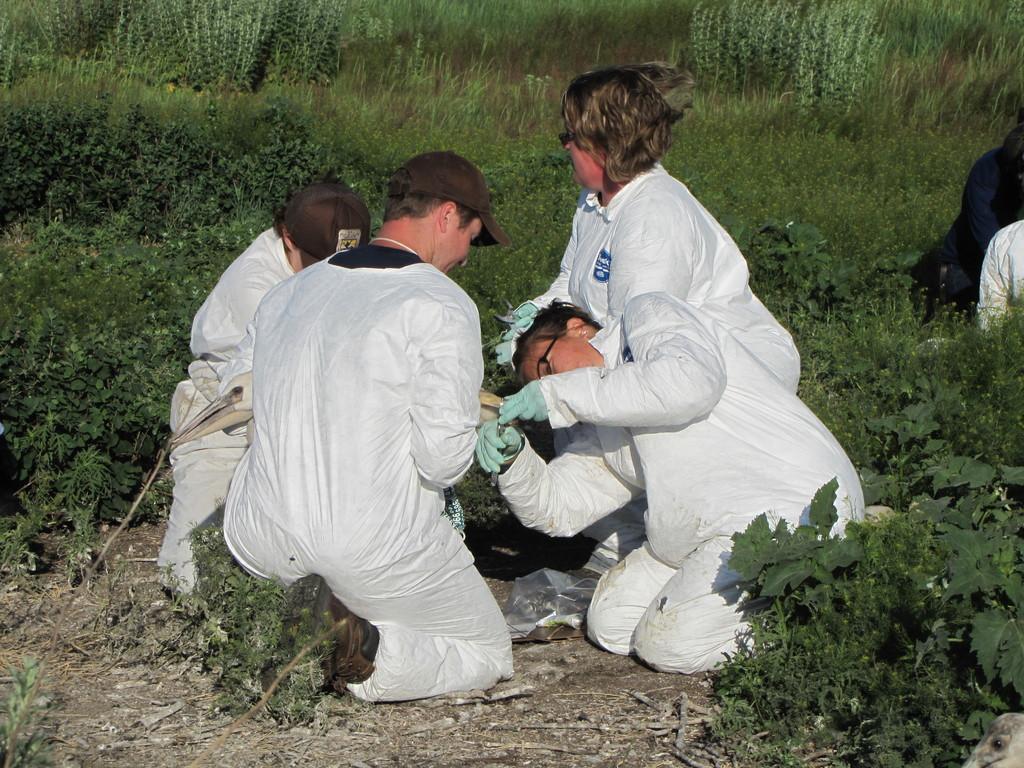Can you describe this image briefly? In the foreground of the picture I can see four persons. They are wearing white color clothes and two of them wearing the cap on their heads. I can see two persons on the top right side, through their faces are not visible. In the background, I can see the plants. 